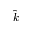<formula> <loc_0><loc_0><loc_500><loc_500>\hat { k }</formula> 